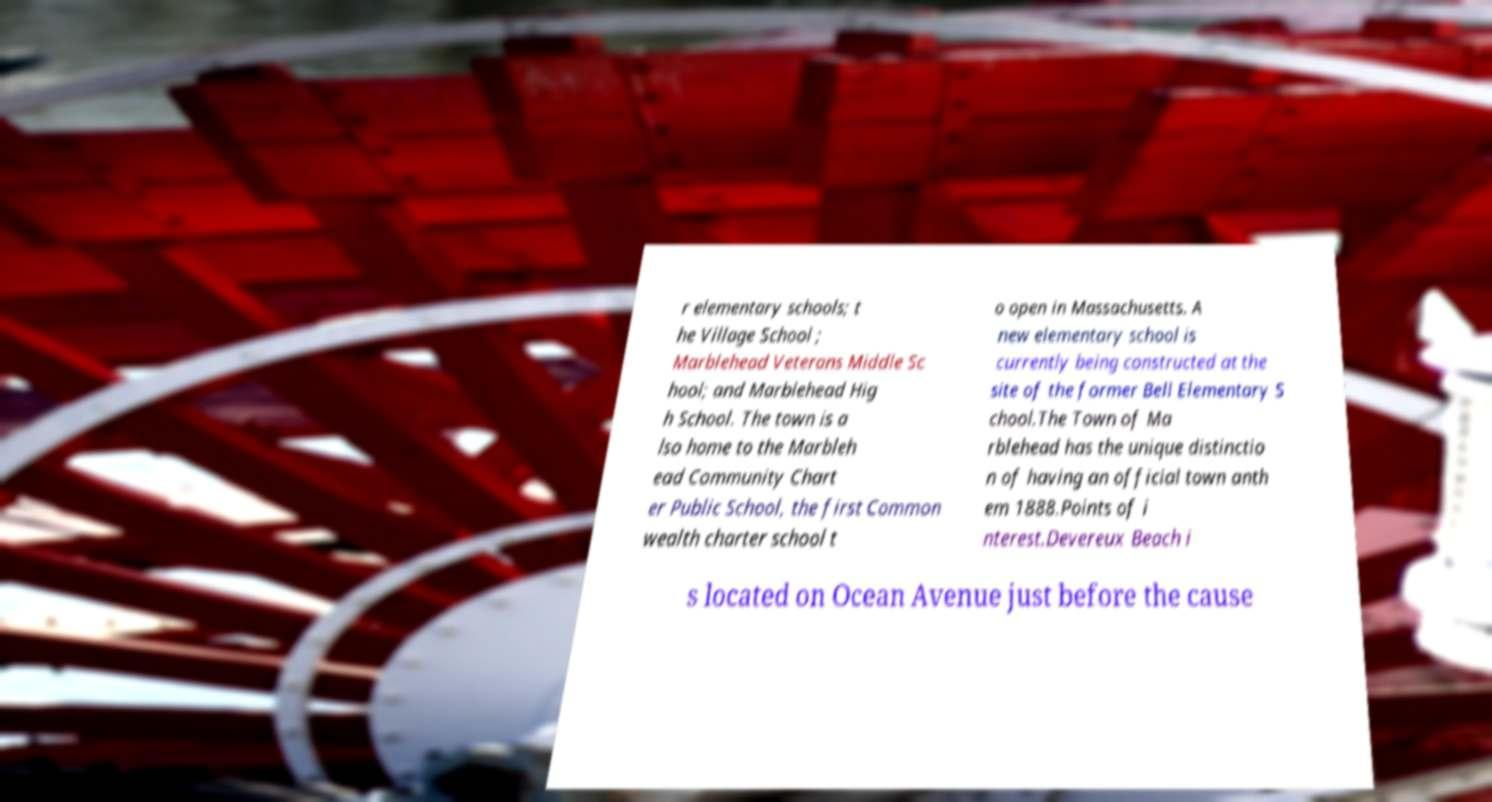I need the written content from this picture converted into text. Can you do that? r elementary schools; t he Village School ; Marblehead Veterans Middle Sc hool; and Marblehead Hig h School. The town is a lso home to the Marbleh ead Community Chart er Public School, the first Common wealth charter school t o open in Massachusetts. A new elementary school is currently being constructed at the site of the former Bell Elementary S chool.The Town of Ma rblehead has the unique distinctio n of having an official town anth em 1888.Points of i nterest.Devereux Beach i s located on Ocean Avenue just before the cause 